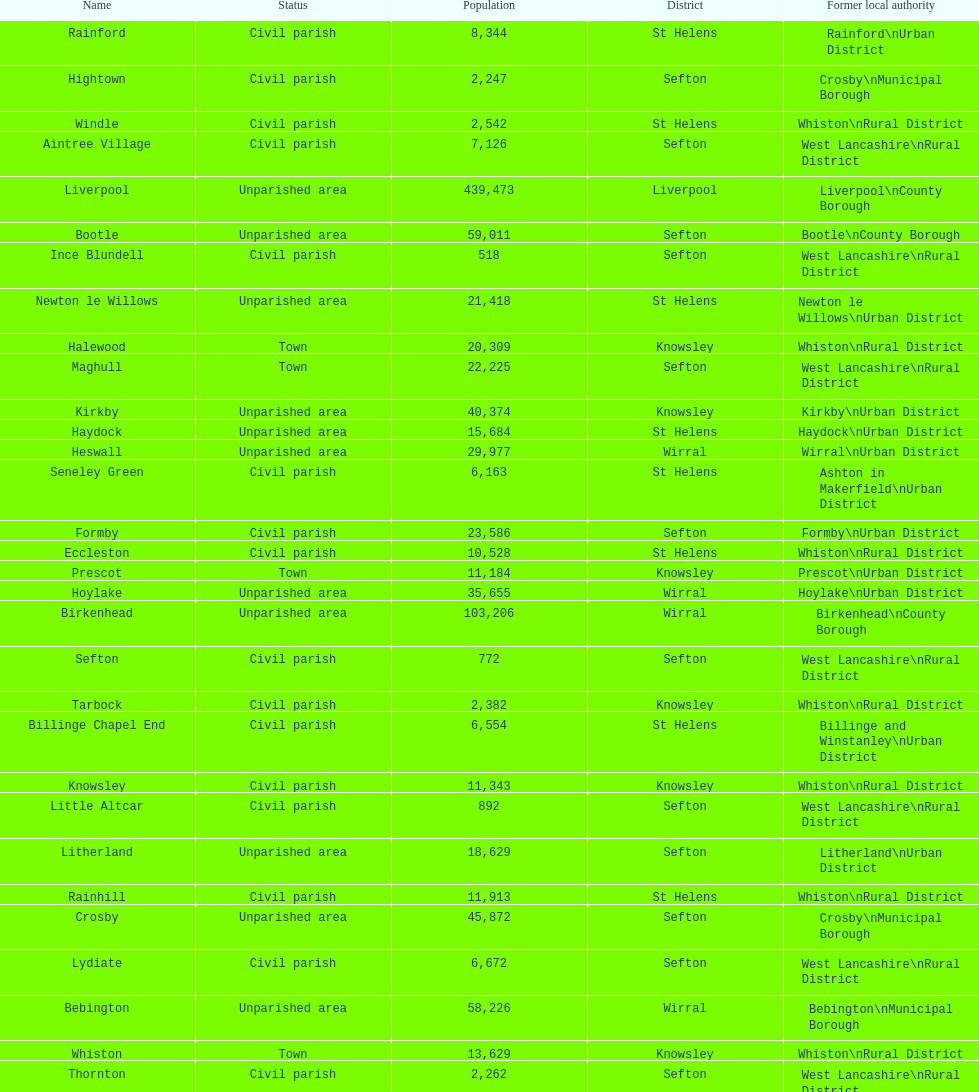How many civil parishes have population counts of at least 10,000? 4. Write the full table. {'header': ['Name', 'Status', 'Population', 'District', 'Former local authority'], 'rows': [['Rainford', 'Civil parish', '8,344', 'St Helens', 'Rainford\\nUrban District'], ['Hightown', 'Civil parish', '2,247', 'Sefton', 'Crosby\\nMunicipal Borough'], ['Windle', 'Civil parish', '2,542', 'St Helens', 'Whiston\\nRural District'], ['Aintree Village', 'Civil parish', '7,126', 'Sefton', 'West Lancashire\\nRural District'], ['Liverpool', 'Unparished area', '439,473', 'Liverpool', 'Liverpool\\nCounty Borough'], ['Bootle', 'Unparished area', '59,011', 'Sefton', 'Bootle\\nCounty Borough'], ['Ince Blundell', 'Civil parish', '518', 'Sefton', 'West Lancashire\\nRural District'], ['Newton le Willows', 'Unparished area', '21,418', 'St Helens', 'Newton le Willows\\nUrban District'], ['Halewood', 'Town', '20,309', 'Knowsley', 'Whiston\\nRural District'], ['Maghull', 'Town', '22,225', 'Sefton', 'West Lancashire\\nRural District'], ['Kirkby', 'Unparished area', '40,374', 'Knowsley', 'Kirkby\\nUrban District'], ['Haydock', 'Unparished area', '15,684', 'St Helens', 'Haydock\\nUrban District'], ['Heswall', 'Unparished area', '29,977', 'Wirral', 'Wirral\\nUrban District'], ['Seneley Green', 'Civil parish', '6,163', 'St Helens', 'Ashton in Makerfield\\nUrban District'], ['Formby', 'Civil parish', '23,586', 'Sefton', 'Formby\\nUrban District'], ['Eccleston', 'Civil parish', '10,528', 'St Helens', 'Whiston\\nRural District'], ['Prescot', 'Town', '11,184', 'Knowsley', 'Prescot\\nUrban District'], ['Hoylake', 'Unparished area', '35,655', 'Wirral', 'Hoylake\\nUrban District'], ['Birkenhead', 'Unparished area', '103,206', 'Wirral', 'Birkenhead\\nCounty Borough'], ['Sefton', 'Civil parish', '772', 'Sefton', 'West Lancashire\\nRural District'], ['Tarbock', 'Civil parish', '2,382', 'Knowsley', 'Whiston\\nRural District'], ['Billinge Chapel End', 'Civil parish', '6,554', 'St Helens', 'Billinge and Winstanley\\nUrban District'], ['Knowsley', 'Civil parish', '11,343', 'Knowsley', 'Whiston\\nRural District'], ['Little Altcar', 'Civil parish', '892', 'Sefton', 'West Lancashire\\nRural District'], ['Litherland', 'Unparished area', '18,629', 'Sefton', 'Litherland\\nUrban District'], ['Rainhill', 'Civil parish', '11,913', 'St Helens', 'Whiston\\nRural District'], ['Crosby', 'Unparished area', '45,872', 'Sefton', 'Crosby\\nMunicipal Borough'], ['Lydiate', 'Civil parish', '6,672', 'Sefton', 'West Lancashire\\nRural District'], ['Bebington', 'Unparished area', '58,226', 'Wirral', 'Bebington\\nMunicipal Borough'], ['Whiston', 'Town', '13,629', 'Knowsley', 'Whiston\\nRural District'], ['Thornton', 'Civil parish', '2,262', 'Sefton', 'West Lancashire\\nRural District'], ['Southport', 'Unparished area', '90,336', 'Sefton', 'Southport\\nCounty Borough'], ['Huyton with Roby', 'Unparished area', '49,859', 'Knowsley', 'Huyton with Roby\\nUrban District'], ['Wallasey', 'Unparished area', '84,348', 'Wirral', 'Wallasey\\nCounty Borough'], ['Melling', 'Civil parish', '2,810', 'Sefton', 'West Lancashire\\nRural District'], ['St Helens', 'Unparished area', '91,414', 'St Helens', 'St Helens\\nCounty Borough'], ['Cronton', 'Civil parish', '1,379', 'Knowsley', 'Whiston\\nRural District'], ['Bold', 'Civil parish', '2,283', 'St Helens', 'Whiston\\nRural District']]} 